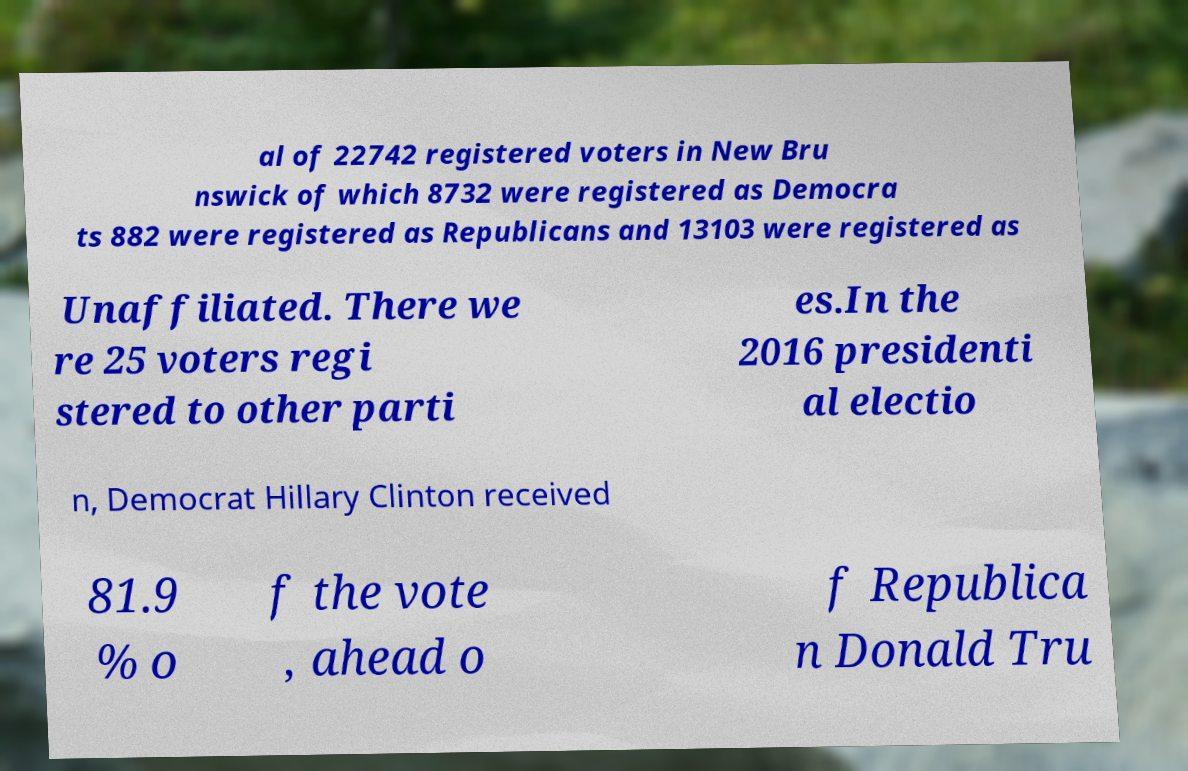What messages or text are displayed in this image? I need them in a readable, typed format. al of 22742 registered voters in New Bru nswick of which 8732 were registered as Democra ts 882 were registered as Republicans and 13103 were registered as Unaffiliated. There we re 25 voters regi stered to other parti es.In the 2016 presidenti al electio n, Democrat Hillary Clinton received 81.9 % o f the vote , ahead o f Republica n Donald Tru 